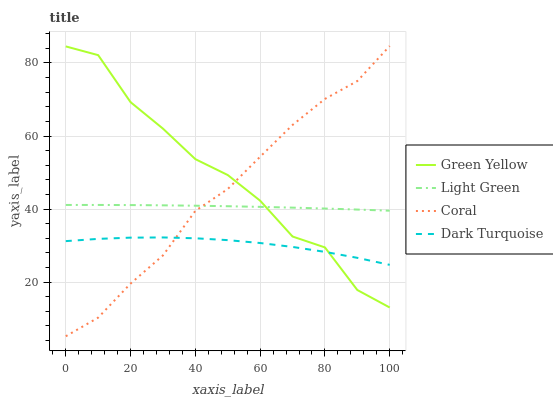Does Coral have the minimum area under the curve?
Answer yes or no. No. Does Coral have the maximum area under the curve?
Answer yes or no. No. Is Coral the smoothest?
Answer yes or no. No. Is Coral the roughest?
Answer yes or no. No. Does Green Yellow have the lowest value?
Answer yes or no. No. Does Green Yellow have the highest value?
Answer yes or no. No. Is Dark Turquoise less than Light Green?
Answer yes or no. Yes. Is Light Green greater than Dark Turquoise?
Answer yes or no. Yes. Does Dark Turquoise intersect Light Green?
Answer yes or no. No. 